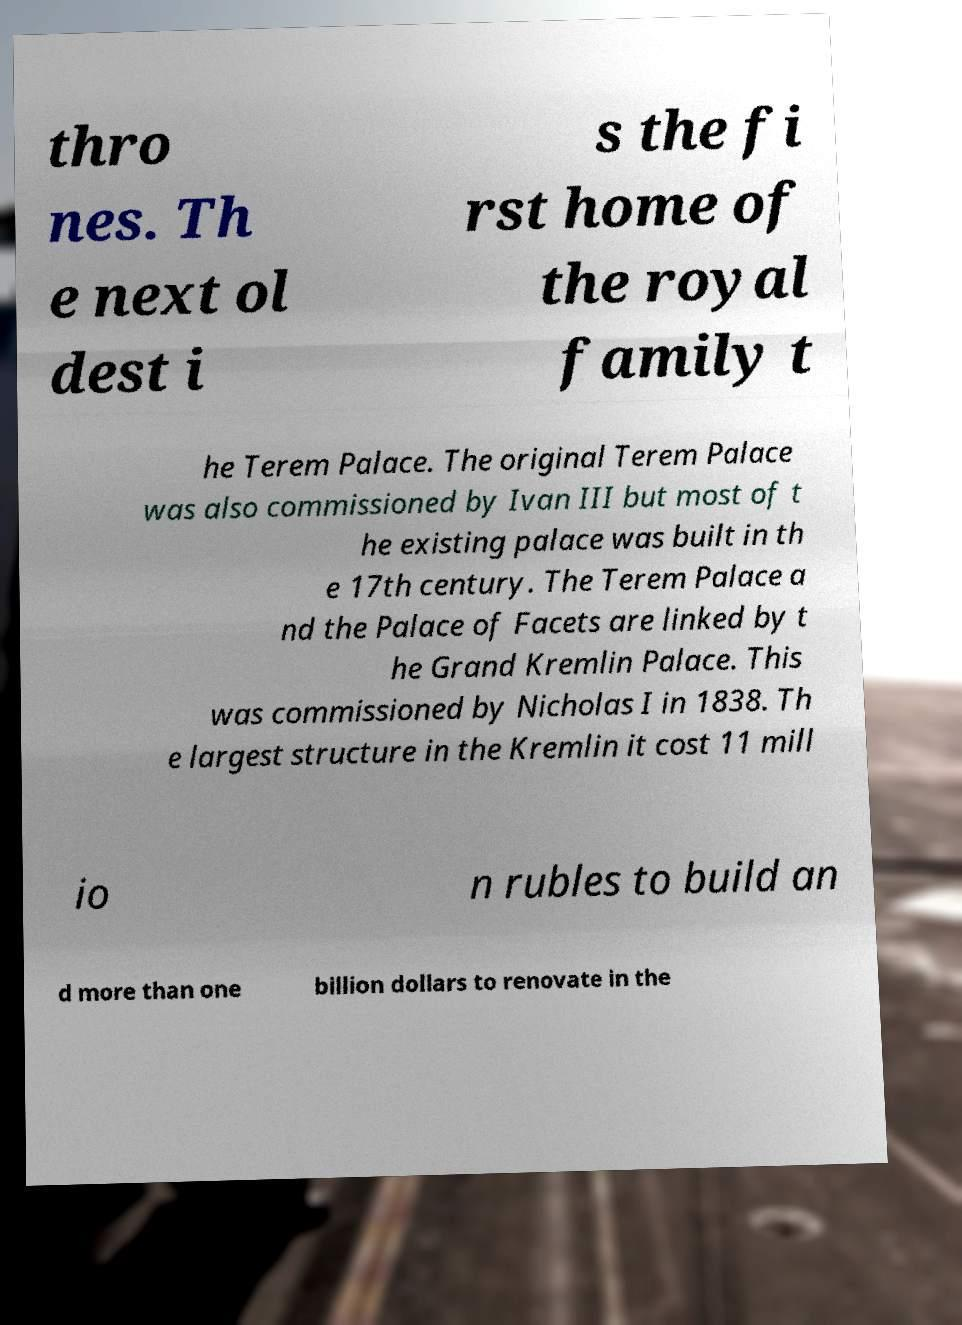For documentation purposes, I need the text within this image transcribed. Could you provide that? thro nes. Th e next ol dest i s the fi rst home of the royal family t he Terem Palace. The original Terem Palace was also commissioned by Ivan III but most of t he existing palace was built in th e 17th century. The Terem Palace a nd the Palace of Facets are linked by t he Grand Kremlin Palace. This was commissioned by Nicholas I in 1838. Th e largest structure in the Kremlin it cost 11 mill io n rubles to build an d more than one billion dollars to renovate in the 